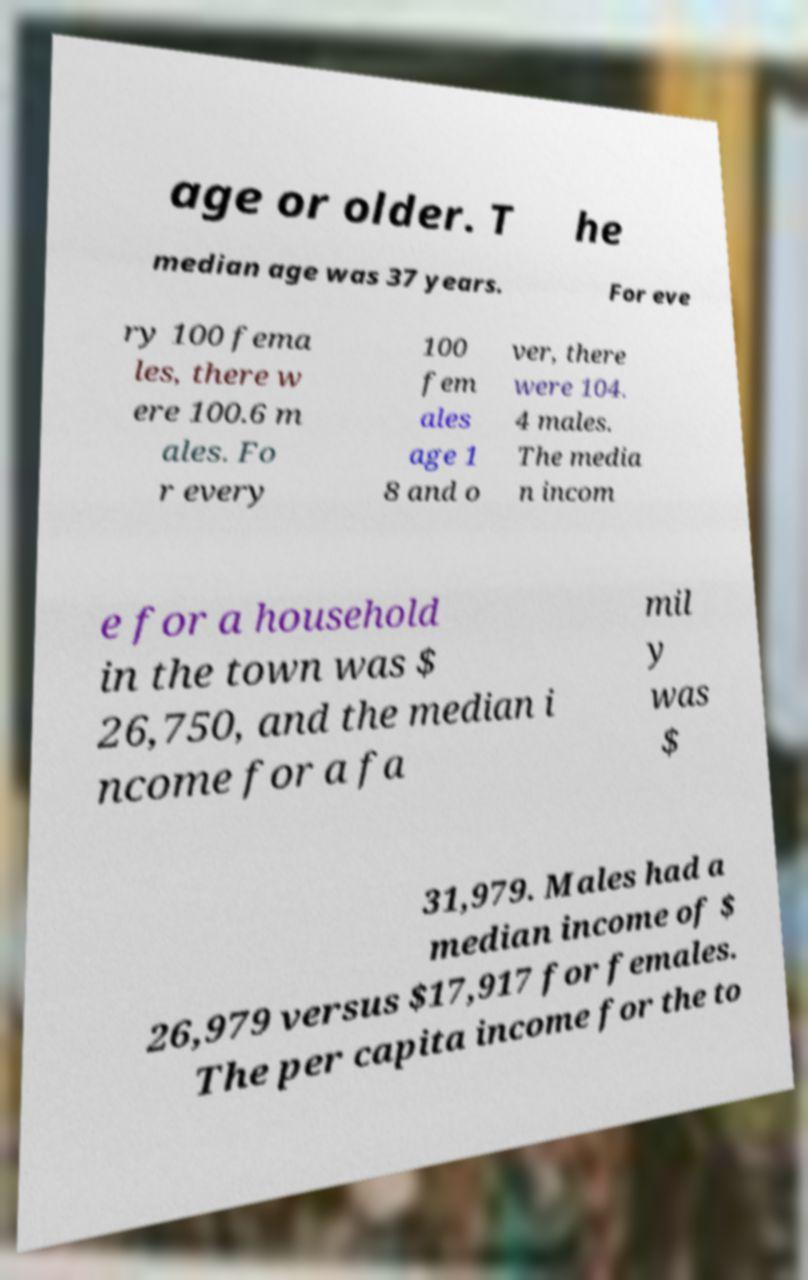I need the written content from this picture converted into text. Can you do that? age or older. T he median age was 37 years. For eve ry 100 fema les, there w ere 100.6 m ales. Fo r every 100 fem ales age 1 8 and o ver, there were 104. 4 males. The media n incom e for a household in the town was $ 26,750, and the median i ncome for a fa mil y was $ 31,979. Males had a median income of $ 26,979 versus $17,917 for females. The per capita income for the to 